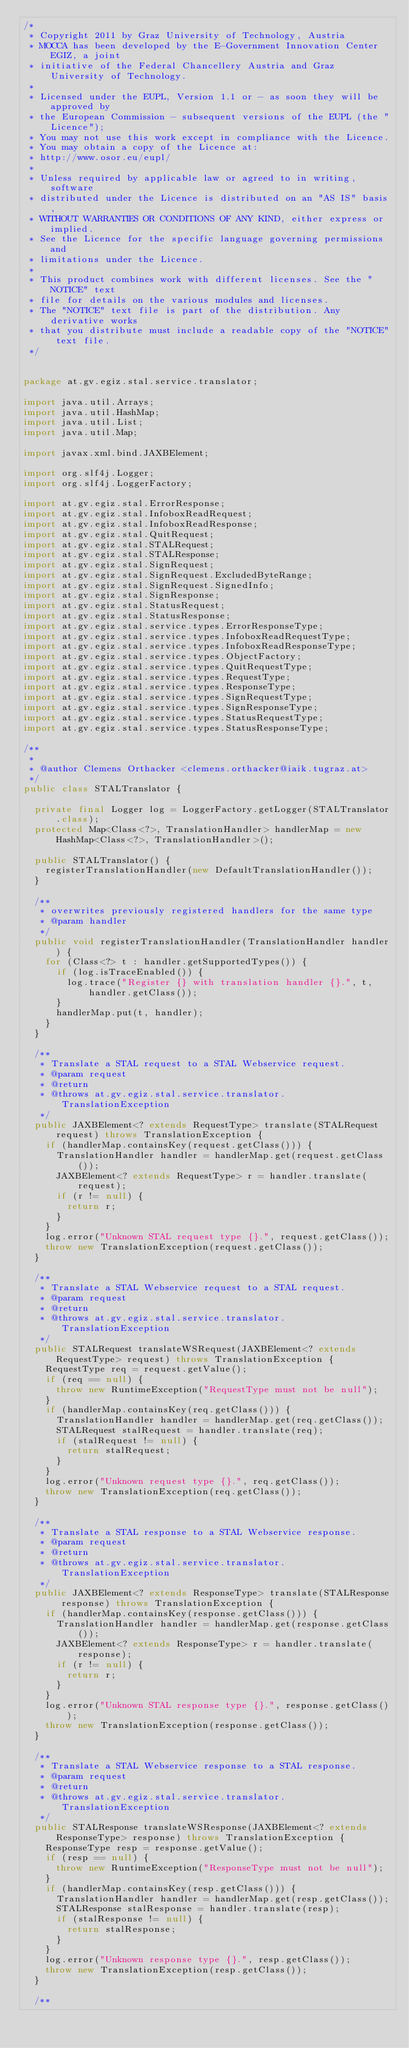<code> <loc_0><loc_0><loc_500><loc_500><_Java_>/*
 * Copyright 2011 by Graz University of Technology, Austria
 * MOCCA has been developed by the E-Government Innovation Center EGIZ, a joint
 * initiative of the Federal Chancellery Austria and Graz University of Technology.
 *
 * Licensed under the EUPL, Version 1.1 or - as soon they will be approved by
 * the European Commission - subsequent versions of the EUPL (the "Licence");
 * You may not use this work except in compliance with the Licence.
 * You may obtain a copy of the Licence at:
 * http://www.osor.eu/eupl/
 *
 * Unless required by applicable law or agreed to in writing, software
 * distributed under the Licence is distributed on an "AS IS" basis,
 * WITHOUT WARRANTIES OR CONDITIONS OF ANY KIND, either express or implied.
 * See the Licence for the specific language governing permissions and
 * limitations under the Licence.
 *
 * This product combines work with different licenses. See the "NOTICE" text
 * file for details on the various modules and licenses.
 * The "NOTICE" text file is part of the distribution. Any derivative works
 * that you distribute must include a readable copy of the "NOTICE" text file.
 */


package at.gv.egiz.stal.service.translator;

import java.util.Arrays;
import java.util.HashMap;
import java.util.List;
import java.util.Map;

import javax.xml.bind.JAXBElement;

import org.slf4j.Logger;
import org.slf4j.LoggerFactory;

import at.gv.egiz.stal.ErrorResponse;
import at.gv.egiz.stal.InfoboxReadRequest;
import at.gv.egiz.stal.InfoboxReadResponse;
import at.gv.egiz.stal.QuitRequest;
import at.gv.egiz.stal.STALRequest;
import at.gv.egiz.stal.STALResponse;
import at.gv.egiz.stal.SignRequest;
import at.gv.egiz.stal.SignRequest.ExcludedByteRange;
import at.gv.egiz.stal.SignRequest.SignedInfo;
import at.gv.egiz.stal.SignResponse;
import at.gv.egiz.stal.StatusRequest;
import at.gv.egiz.stal.StatusResponse;
import at.gv.egiz.stal.service.types.ErrorResponseType;
import at.gv.egiz.stal.service.types.InfoboxReadRequestType;
import at.gv.egiz.stal.service.types.InfoboxReadResponseType;
import at.gv.egiz.stal.service.types.ObjectFactory;
import at.gv.egiz.stal.service.types.QuitRequestType;
import at.gv.egiz.stal.service.types.RequestType;
import at.gv.egiz.stal.service.types.ResponseType;
import at.gv.egiz.stal.service.types.SignRequestType;
import at.gv.egiz.stal.service.types.SignResponseType;
import at.gv.egiz.stal.service.types.StatusRequestType;
import at.gv.egiz.stal.service.types.StatusResponseType;

/**
 *
 * @author Clemens Orthacker <clemens.orthacker@iaik.tugraz.at>
 */
public class STALTranslator {

  private final Logger log = LoggerFactory.getLogger(STALTranslator.class);
  protected Map<Class<?>, TranslationHandler> handlerMap = new HashMap<Class<?>, TranslationHandler>();

  public STALTranslator() {
    registerTranslationHandler(new DefaultTranslationHandler());
  }

  /**
   * overwrites previously registered handlers for the same type
   * @param handler
   */
  public void registerTranslationHandler(TranslationHandler handler) {
    for (Class<?> t : handler.getSupportedTypes()) {
      if (log.isTraceEnabled()) {
        log.trace("Register {} with translation handler {}.", t, handler.getClass());
      }
      handlerMap.put(t, handler);
    }
  }

  /**
   * Translate a STAL request to a STAL Webservice request.
   * @param request
   * @return
   * @throws at.gv.egiz.stal.service.translator.TranslationException
   */
  public JAXBElement<? extends RequestType> translate(STALRequest request) throws TranslationException {
    if (handlerMap.containsKey(request.getClass())) {
      TranslationHandler handler = handlerMap.get(request.getClass());
      JAXBElement<? extends RequestType> r = handler.translate(request);
      if (r != null) {
        return r;
      }
    }
    log.error("Unknown STAL request type {}.", request.getClass());
    throw new TranslationException(request.getClass());
  }

  /**
   * Translate a STAL Webservice request to a STAL request.
   * @param request
   * @return
   * @throws at.gv.egiz.stal.service.translator.TranslationException
   */
  public STALRequest translateWSRequest(JAXBElement<? extends RequestType> request) throws TranslationException {
    RequestType req = request.getValue();
    if (req == null) {
      throw new RuntimeException("RequestType must not be null");
    }
    if (handlerMap.containsKey(req.getClass())) {
      TranslationHandler handler = handlerMap.get(req.getClass());
      STALRequest stalRequest = handler.translate(req);
      if (stalRequest != null) {
        return stalRequest;
      }
    }
    log.error("Unknown request type {}.", req.getClass());
    throw new TranslationException(req.getClass());
  }

  /**
   * Translate a STAL response to a STAL Webservice response.
   * @param request
   * @return
   * @throws at.gv.egiz.stal.service.translator.TranslationException
   */
  public JAXBElement<? extends ResponseType> translate(STALResponse response) throws TranslationException {
    if (handlerMap.containsKey(response.getClass())) {
      TranslationHandler handler = handlerMap.get(response.getClass());
      JAXBElement<? extends ResponseType> r = handler.translate(response);
      if (r != null) {
        return r;
      }
    }
    log.error("Unknown STAL response type {}.", response.getClass());
    throw new TranslationException(response.getClass());
  }

  /**
   * Translate a STAL Webservice response to a STAL response.
   * @param request
   * @return
   * @throws at.gv.egiz.stal.service.translator.TranslationException
   */
  public STALResponse translateWSResponse(JAXBElement<? extends ResponseType> response) throws TranslationException {
    ResponseType resp = response.getValue();
    if (resp == null) {
      throw new RuntimeException("ResponseType must not be null");
    }
    if (handlerMap.containsKey(resp.getClass())) {
      TranslationHandler handler = handlerMap.get(resp.getClass());
      STALResponse stalResponse = handler.translate(resp);
      if (stalResponse != null) {
        return stalResponse;
      }
    }
    log.error("Unknown response type {}.", resp.getClass());
    throw new TranslationException(resp.getClass());
  }

  /**</code> 